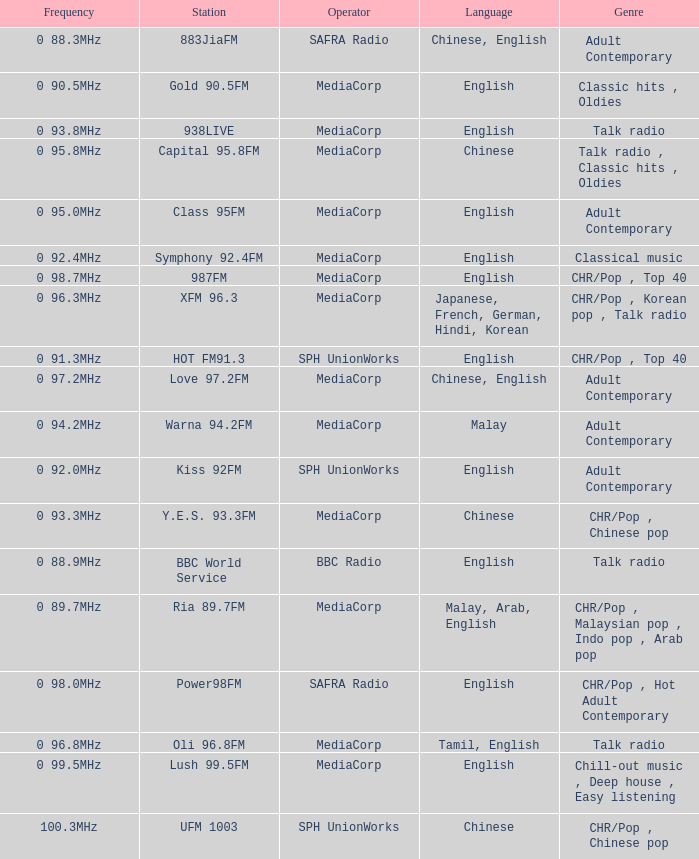What is the genre of the BBC World Service? Talk radio. 